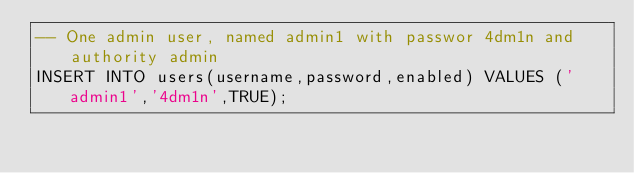<code> <loc_0><loc_0><loc_500><loc_500><_SQL_>-- One admin user, named admin1 with passwor 4dm1n and authority admin
INSERT INTO users(username,password,enabled) VALUES ('admin1','4dm1n',TRUE);</code> 